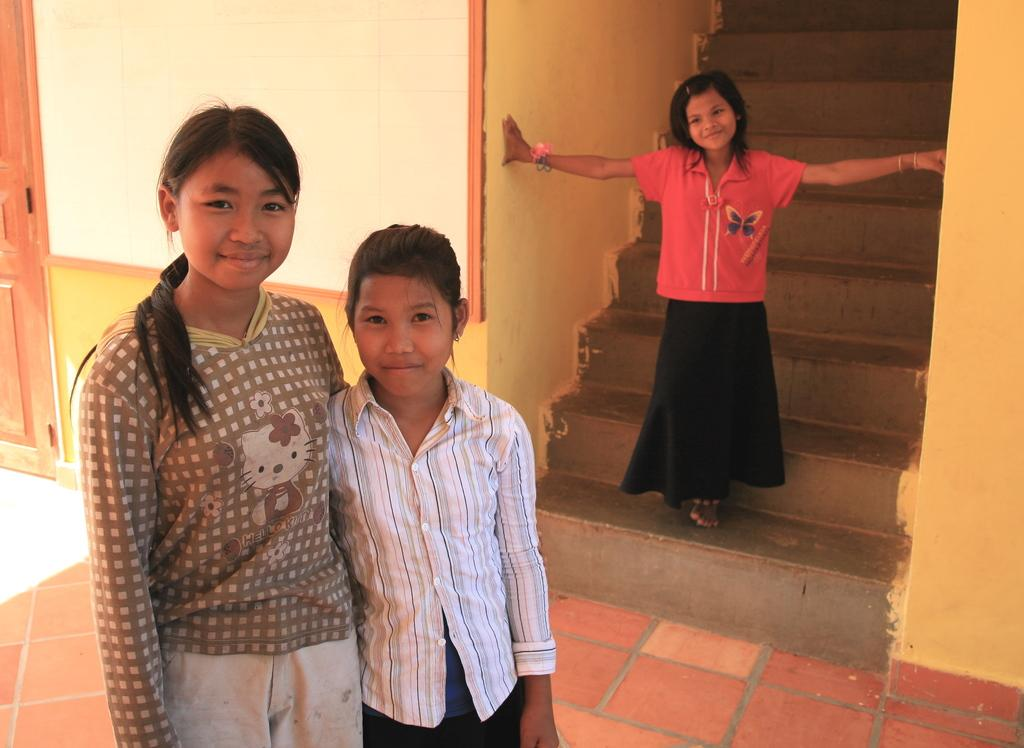Who or what is present in the image? There are kids in the image. What architectural feature can be seen in the image? There is a staircase in the image. What is on the left side of the image? There is a wall on the left side of the image. What is at the bottom of the image? There is a floor at the bottom of the image. What is the value of the tramp in the image? There is no tramp present in the image, so it is not possible to determine its value. 